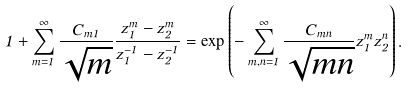<formula> <loc_0><loc_0><loc_500><loc_500>1 + \sum _ { m = 1 } ^ { \infty } \frac { C _ { m 1 } } { \sqrt { m } } \frac { z _ { 1 } ^ { m } - z _ { 2 } ^ { m } } { z ^ { - 1 } _ { 1 } - z ^ { - 1 } _ { 2 } } = \exp \left ( - \sum _ { m , n = 1 } ^ { \infty } \frac { C _ { m n } } { \sqrt { m n } } z _ { 1 } ^ { m } z _ { 2 } ^ { n } \right ) .</formula> 